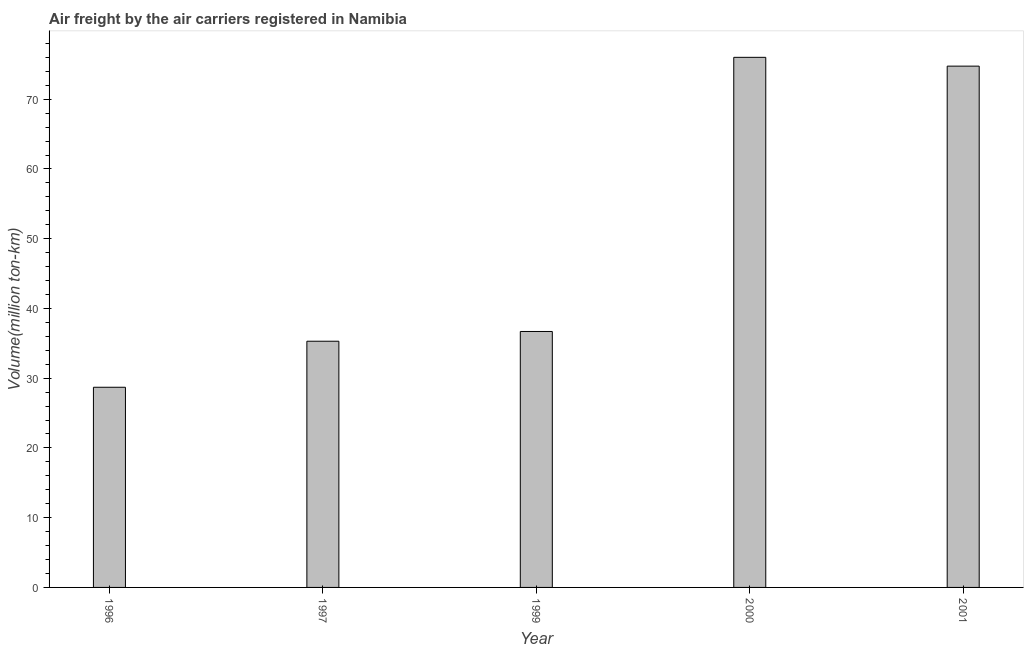Does the graph contain any zero values?
Offer a very short reply. No. What is the title of the graph?
Give a very brief answer. Air freight by the air carriers registered in Namibia. What is the label or title of the Y-axis?
Give a very brief answer. Volume(million ton-km). What is the air freight in 1996?
Make the answer very short. 28.7. Across all years, what is the maximum air freight?
Make the answer very short. 76.01. Across all years, what is the minimum air freight?
Your response must be concise. 28.7. In which year was the air freight minimum?
Give a very brief answer. 1996. What is the sum of the air freight?
Keep it short and to the point. 251.45. What is the difference between the air freight in 1996 and 2000?
Your answer should be very brief. -47.31. What is the average air freight per year?
Offer a very short reply. 50.29. What is the median air freight?
Your response must be concise. 36.7. Do a majority of the years between 2000 and 1996 (inclusive) have air freight greater than 70 million ton-km?
Keep it short and to the point. Yes. Is the air freight in 1999 less than that in 2001?
Offer a terse response. Yes. Is the difference between the air freight in 1999 and 2000 greater than the difference between any two years?
Provide a short and direct response. No. What is the difference between the highest and the second highest air freight?
Your response must be concise. 1.26. Is the sum of the air freight in 1997 and 2000 greater than the maximum air freight across all years?
Your response must be concise. Yes. What is the difference between the highest and the lowest air freight?
Make the answer very short. 47.31. In how many years, is the air freight greater than the average air freight taken over all years?
Your response must be concise. 2. How many bars are there?
Provide a short and direct response. 5. Are all the bars in the graph horizontal?
Provide a succinct answer. No. Are the values on the major ticks of Y-axis written in scientific E-notation?
Your answer should be compact. No. What is the Volume(million ton-km) of 1996?
Your answer should be compact. 28.7. What is the Volume(million ton-km) of 1997?
Provide a succinct answer. 35.3. What is the Volume(million ton-km) of 1999?
Offer a very short reply. 36.7. What is the Volume(million ton-km) in 2000?
Your response must be concise. 76.01. What is the Volume(million ton-km) in 2001?
Your answer should be very brief. 74.74. What is the difference between the Volume(million ton-km) in 1996 and 1997?
Keep it short and to the point. -6.6. What is the difference between the Volume(million ton-km) in 1996 and 2000?
Offer a very short reply. -47.31. What is the difference between the Volume(million ton-km) in 1996 and 2001?
Your answer should be compact. -46.04. What is the difference between the Volume(million ton-km) in 1997 and 1999?
Your answer should be compact. -1.4. What is the difference between the Volume(million ton-km) in 1997 and 2000?
Ensure brevity in your answer.  -40.71. What is the difference between the Volume(million ton-km) in 1997 and 2001?
Provide a short and direct response. -39.44. What is the difference between the Volume(million ton-km) in 1999 and 2000?
Keep it short and to the point. -39.31. What is the difference between the Volume(million ton-km) in 1999 and 2001?
Offer a very short reply. -38.04. What is the difference between the Volume(million ton-km) in 2000 and 2001?
Your answer should be compact. 1.26. What is the ratio of the Volume(million ton-km) in 1996 to that in 1997?
Provide a short and direct response. 0.81. What is the ratio of the Volume(million ton-km) in 1996 to that in 1999?
Make the answer very short. 0.78. What is the ratio of the Volume(million ton-km) in 1996 to that in 2000?
Offer a very short reply. 0.38. What is the ratio of the Volume(million ton-km) in 1996 to that in 2001?
Provide a succinct answer. 0.38. What is the ratio of the Volume(million ton-km) in 1997 to that in 1999?
Your answer should be compact. 0.96. What is the ratio of the Volume(million ton-km) in 1997 to that in 2000?
Provide a succinct answer. 0.46. What is the ratio of the Volume(million ton-km) in 1997 to that in 2001?
Your answer should be very brief. 0.47. What is the ratio of the Volume(million ton-km) in 1999 to that in 2000?
Provide a succinct answer. 0.48. What is the ratio of the Volume(million ton-km) in 1999 to that in 2001?
Make the answer very short. 0.49. 